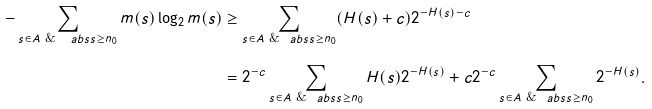<formula> <loc_0><loc_0><loc_500><loc_500>- \sum _ { s \in A \text { \& } \ a b s { s } \geq n _ { 0 } } m ( s ) \log _ { 2 } m ( s ) & \geq \sum _ { s \in A \text { \& } \ a b s { s } \geq n _ { 0 } } ( H ( s ) + c ) 2 ^ { - H ( s ) - c } \\ & = 2 ^ { - c } \sum _ { s \in A \text { \& } \ a b s { s } \geq n _ { 0 } } H ( s ) 2 ^ { - H ( s ) } + c 2 ^ { - c } \sum _ { s \in A \text { \& } \ a b s { s } \geq n _ { 0 } } 2 ^ { - H ( s ) } .</formula> 